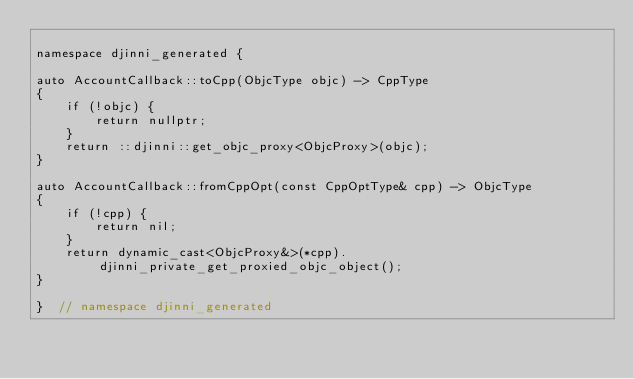<code> <loc_0><loc_0><loc_500><loc_500><_ObjectiveC_>
namespace djinni_generated {

auto AccountCallback::toCpp(ObjcType objc) -> CppType
{
    if (!objc) {
        return nullptr;
    }
    return ::djinni::get_objc_proxy<ObjcProxy>(objc);
}

auto AccountCallback::fromCppOpt(const CppOptType& cpp) -> ObjcType
{
    if (!cpp) {
        return nil;
    }
    return dynamic_cast<ObjcProxy&>(*cpp).djinni_private_get_proxied_objc_object();
}

}  // namespace djinni_generated
</code> 